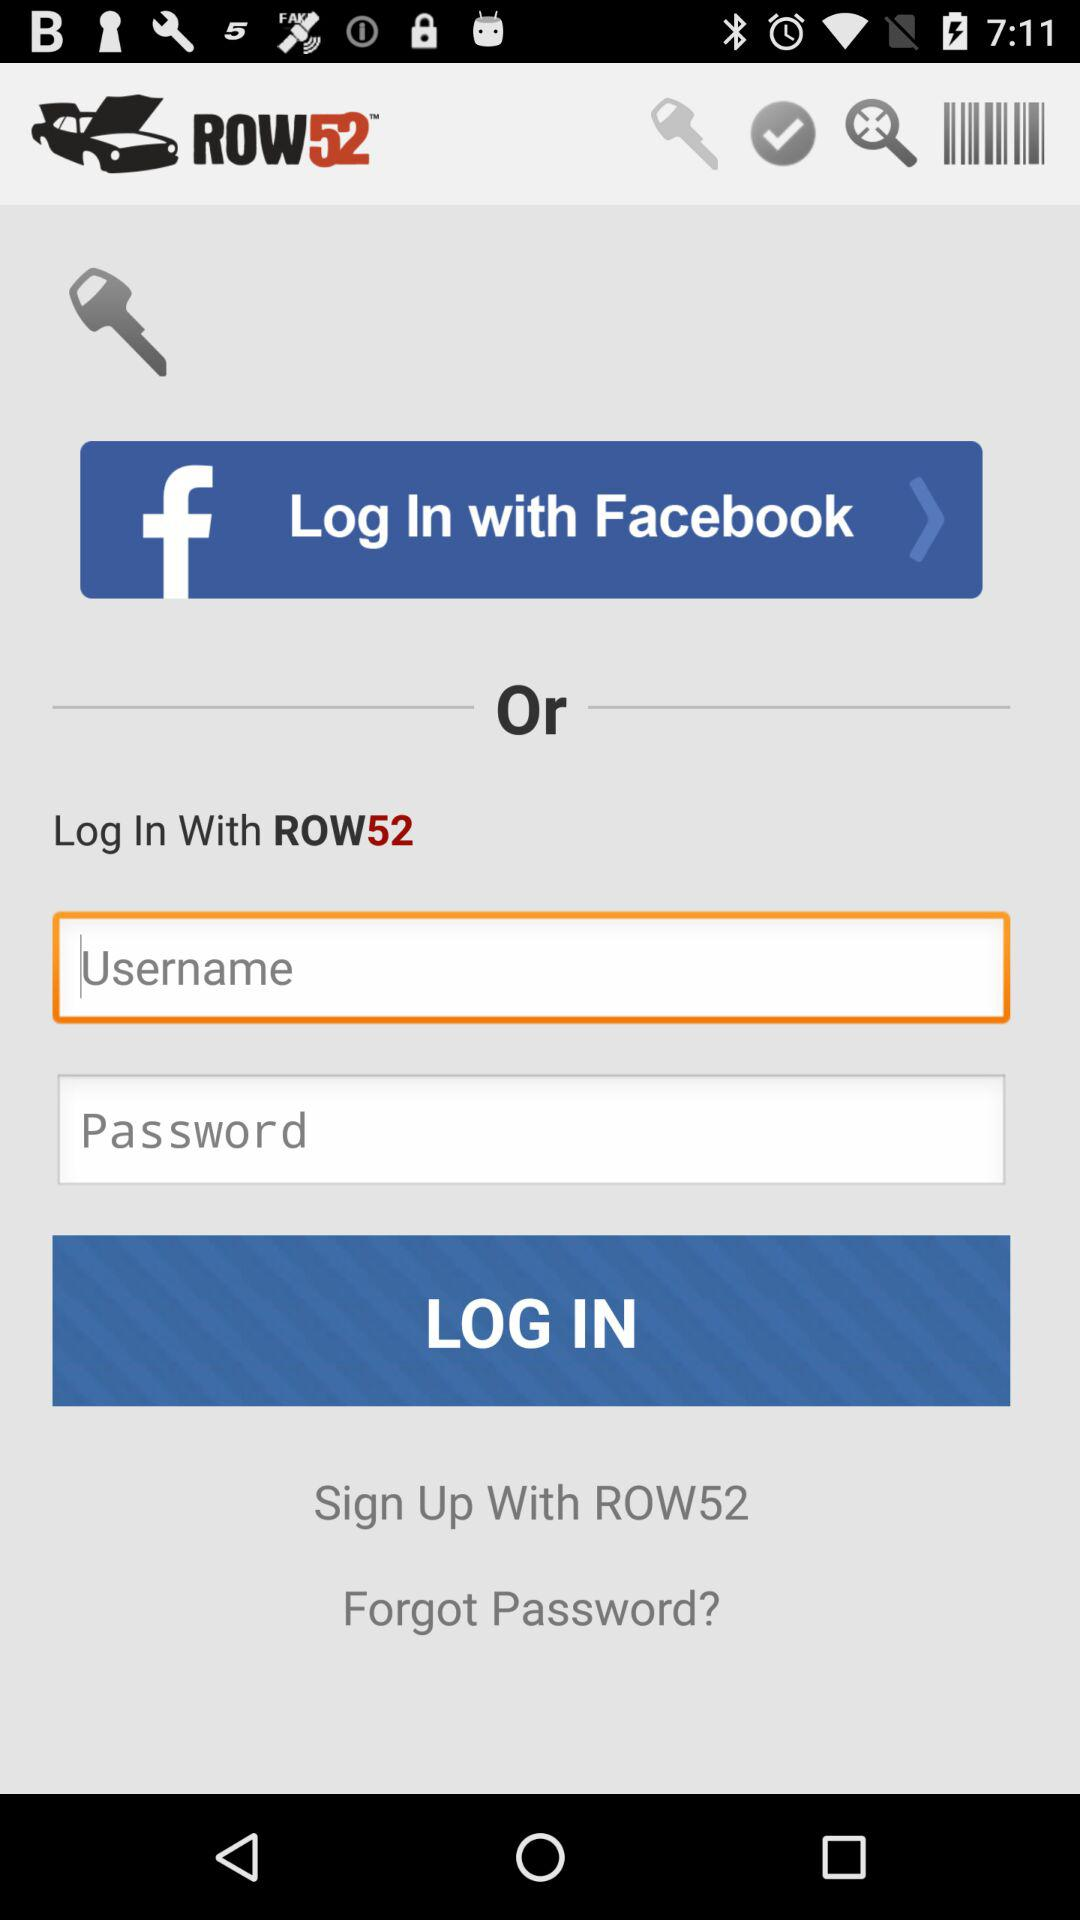What is the app name? The app name is "ROW52". 